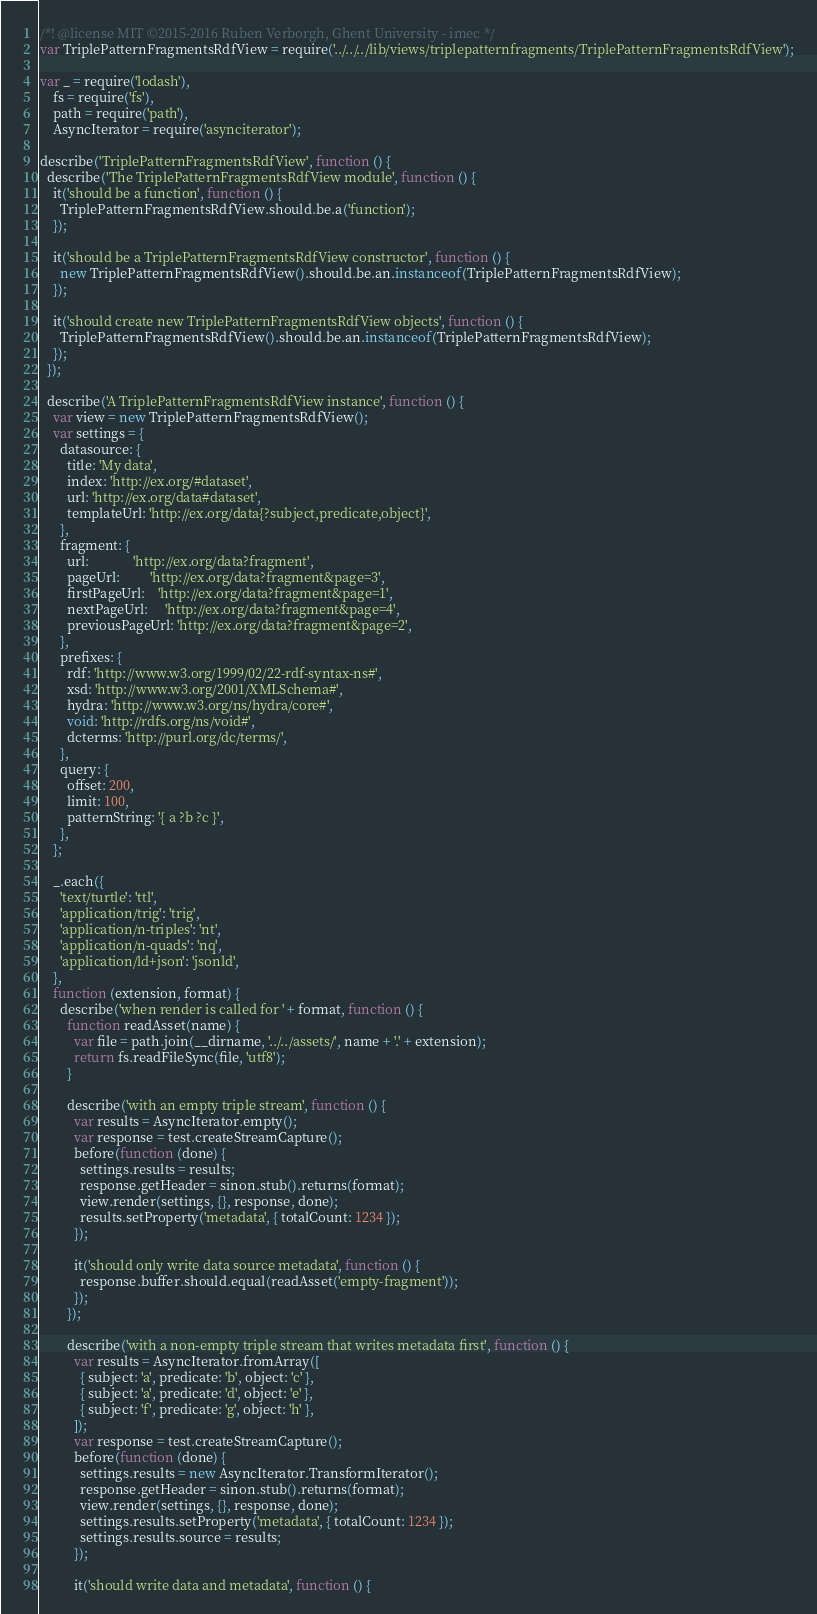Convert code to text. <code><loc_0><loc_0><loc_500><loc_500><_JavaScript_>/*! @license MIT ©2015-2016 Ruben Verborgh, Ghent University - imec */
var TriplePatternFragmentsRdfView = require('../../../lib/views/triplepatternfragments/TriplePatternFragmentsRdfView');

var _ = require('lodash'),
    fs = require('fs'),
    path = require('path'),
    AsyncIterator = require('asynciterator');

describe('TriplePatternFragmentsRdfView', function () {
  describe('The TriplePatternFragmentsRdfView module', function () {
    it('should be a function', function () {
      TriplePatternFragmentsRdfView.should.be.a('function');
    });

    it('should be a TriplePatternFragmentsRdfView constructor', function () {
      new TriplePatternFragmentsRdfView().should.be.an.instanceof(TriplePatternFragmentsRdfView);
    });

    it('should create new TriplePatternFragmentsRdfView objects', function () {
      TriplePatternFragmentsRdfView().should.be.an.instanceof(TriplePatternFragmentsRdfView);
    });
  });

  describe('A TriplePatternFragmentsRdfView instance', function () {
    var view = new TriplePatternFragmentsRdfView();
    var settings = {
      datasource: {
        title: 'My data',
        index: 'http://ex.org/#dataset',
        url: 'http://ex.org/data#dataset',
        templateUrl: 'http://ex.org/data{?subject,predicate,object}',
      },
      fragment: {
        url:             'http://ex.org/data?fragment',
        pageUrl:         'http://ex.org/data?fragment&page=3',
        firstPageUrl:    'http://ex.org/data?fragment&page=1',
        nextPageUrl:     'http://ex.org/data?fragment&page=4',
        previousPageUrl: 'http://ex.org/data?fragment&page=2',
      },
      prefixes: {
        rdf: 'http://www.w3.org/1999/02/22-rdf-syntax-ns#',
        xsd: 'http://www.w3.org/2001/XMLSchema#',
        hydra: 'http://www.w3.org/ns/hydra/core#',
        void: 'http://rdfs.org/ns/void#',
        dcterms: 'http://purl.org/dc/terms/',
      },
      query: {
        offset: 200,
        limit: 100,
        patternString: '{ a ?b ?c }',
      },
    };

    _.each({
      'text/turtle': 'ttl',
      'application/trig': 'trig',
      'application/n-triples': 'nt',
      'application/n-quads': 'nq',
      'application/ld+json': 'jsonld',
    },
    function (extension, format) {
      describe('when render is called for ' + format, function () {
        function readAsset(name) {
          var file = path.join(__dirname, '../../assets/', name + '.' + extension);
          return fs.readFileSync(file, 'utf8');
        }

        describe('with an empty triple stream', function () {
          var results = AsyncIterator.empty();
          var response = test.createStreamCapture();
          before(function (done) {
            settings.results = results;
            response.getHeader = sinon.stub().returns(format);
            view.render(settings, {}, response, done);
            results.setProperty('metadata', { totalCount: 1234 });
          });

          it('should only write data source metadata', function () {
            response.buffer.should.equal(readAsset('empty-fragment'));
          });
        });

        describe('with a non-empty triple stream that writes metadata first', function () {
          var results = AsyncIterator.fromArray([
            { subject: 'a', predicate: 'b', object: 'c' },
            { subject: 'a', predicate: 'd', object: 'e' },
            { subject: 'f', predicate: 'g', object: 'h' },
          ]);
          var response = test.createStreamCapture();
          before(function (done) {
            settings.results = new AsyncIterator.TransformIterator();
            response.getHeader = sinon.stub().returns(format);
            view.render(settings, {}, response, done);
            settings.results.setProperty('metadata', { totalCount: 1234 });
            settings.results.source = results;
          });

          it('should write data and metadata', function () {</code> 